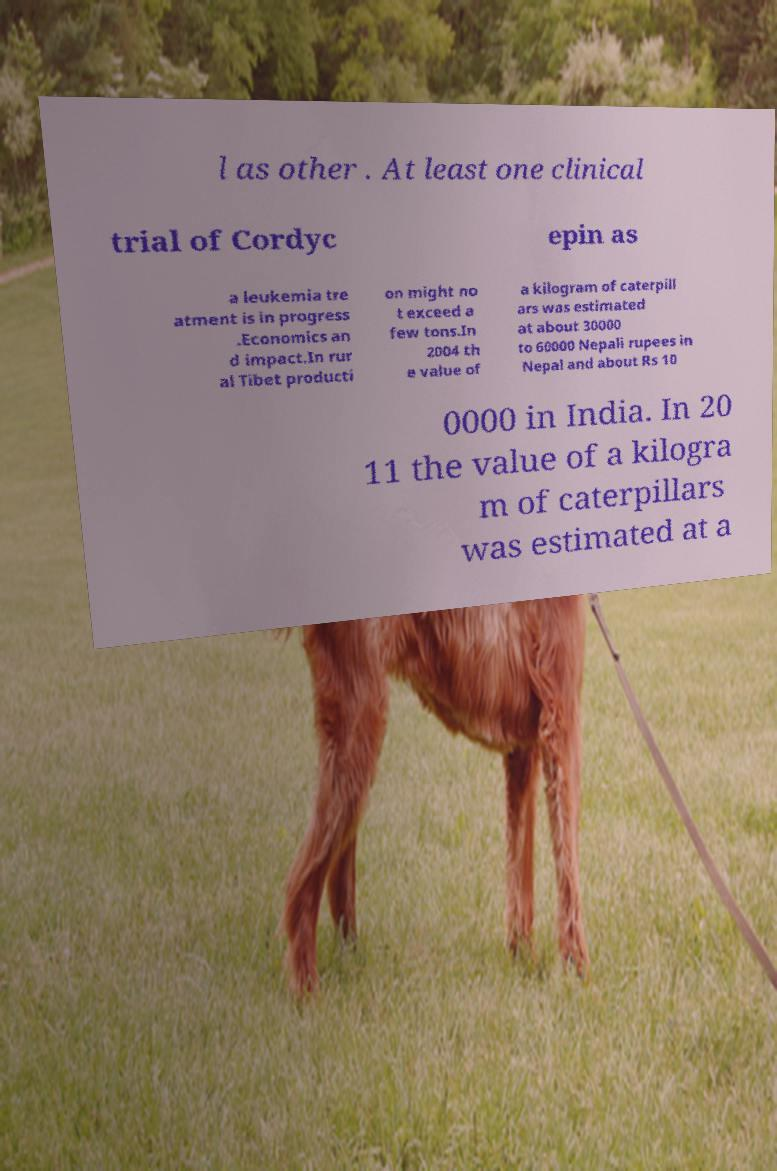Could you extract and type out the text from this image? l as other . At least one clinical trial of Cordyc epin as a leukemia tre atment is in progress .Economics an d impact.In rur al Tibet producti on might no t exceed a few tons.In 2004 th e value of a kilogram of caterpill ars was estimated at about 30000 to 60000 Nepali rupees in Nepal and about Rs 10 0000 in India. In 20 11 the value of a kilogra m of caterpillars was estimated at a 